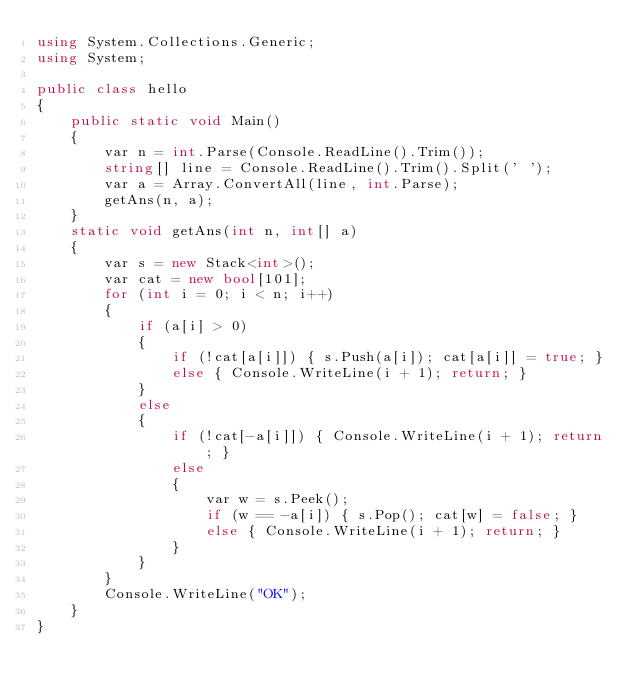Convert code to text. <code><loc_0><loc_0><loc_500><loc_500><_C#_>using System.Collections.Generic;
using System;

public class hello
{
    public static void Main()
    {
        var n = int.Parse(Console.ReadLine().Trim());
        string[] line = Console.ReadLine().Trim().Split(' ');
        var a = Array.ConvertAll(line, int.Parse);
        getAns(n, a);
    }
    static void getAns(int n, int[] a)
    {
        var s = new Stack<int>();
        var cat = new bool[101];
        for (int i = 0; i < n; i++)
        {
            if (a[i] > 0)
            {
                if (!cat[a[i]]) { s.Push(a[i]); cat[a[i]] = true; }
                else { Console.WriteLine(i + 1); return; }
            }
            else
            {
                if (!cat[-a[i]]) { Console.WriteLine(i + 1); return; }
                else
                {
                    var w = s.Peek();
                    if (w == -a[i]) { s.Pop(); cat[w] = false; }
                    else { Console.WriteLine(i + 1); return; }
                }
            }
        }
        Console.WriteLine("OK");
    }
}

</code> 